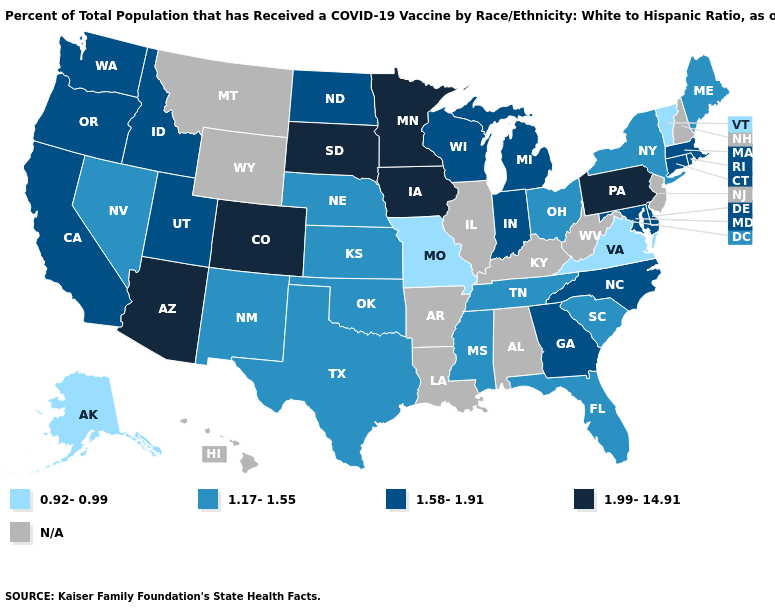Name the states that have a value in the range N/A?
Be succinct. Alabama, Arkansas, Hawaii, Illinois, Kentucky, Louisiana, Montana, New Hampshire, New Jersey, West Virginia, Wyoming. What is the value of New Hampshire?
Answer briefly. N/A. Name the states that have a value in the range 1.99-14.91?
Write a very short answer. Arizona, Colorado, Iowa, Minnesota, Pennsylvania, South Dakota. What is the lowest value in the MidWest?
Give a very brief answer. 0.92-0.99. What is the lowest value in the USA?
Short answer required. 0.92-0.99. Name the states that have a value in the range 1.58-1.91?
Short answer required. California, Connecticut, Delaware, Georgia, Idaho, Indiana, Maryland, Massachusetts, Michigan, North Carolina, North Dakota, Oregon, Rhode Island, Utah, Washington, Wisconsin. Name the states that have a value in the range 1.17-1.55?
Short answer required. Florida, Kansas, Maine, Mississippi, Nebraska, Nevada, New Mexico, New York, Ohio, Oklahoma, South Carolina, Tennessee, Texas. Does Pennsylvania have the highest value in the Northeast?
Be succinct. Yes. Name the states that have a value in the range 0.92-0.99?
Give a very brief answer. Alaska, Missouri, Vermont, Virginia. What is the value of Missouri?
Be succinct. 0.92-0.99. What is the value of Mississippi?
Give a very brief answer. 1.17-1.55. Name the states that have a value in the range N/A?
Be succinct. Alabama, Arkansas, Hawaii, Illinois, Kentucky, Louisiana, Montana, New Hampshire, New Jersey, West Virginia, Wyoming. Is the legend a continuous bar?
Keep it brief. No. Does Vermont have the lowest value in the Northeast?
Write a very short answer. Yes. 